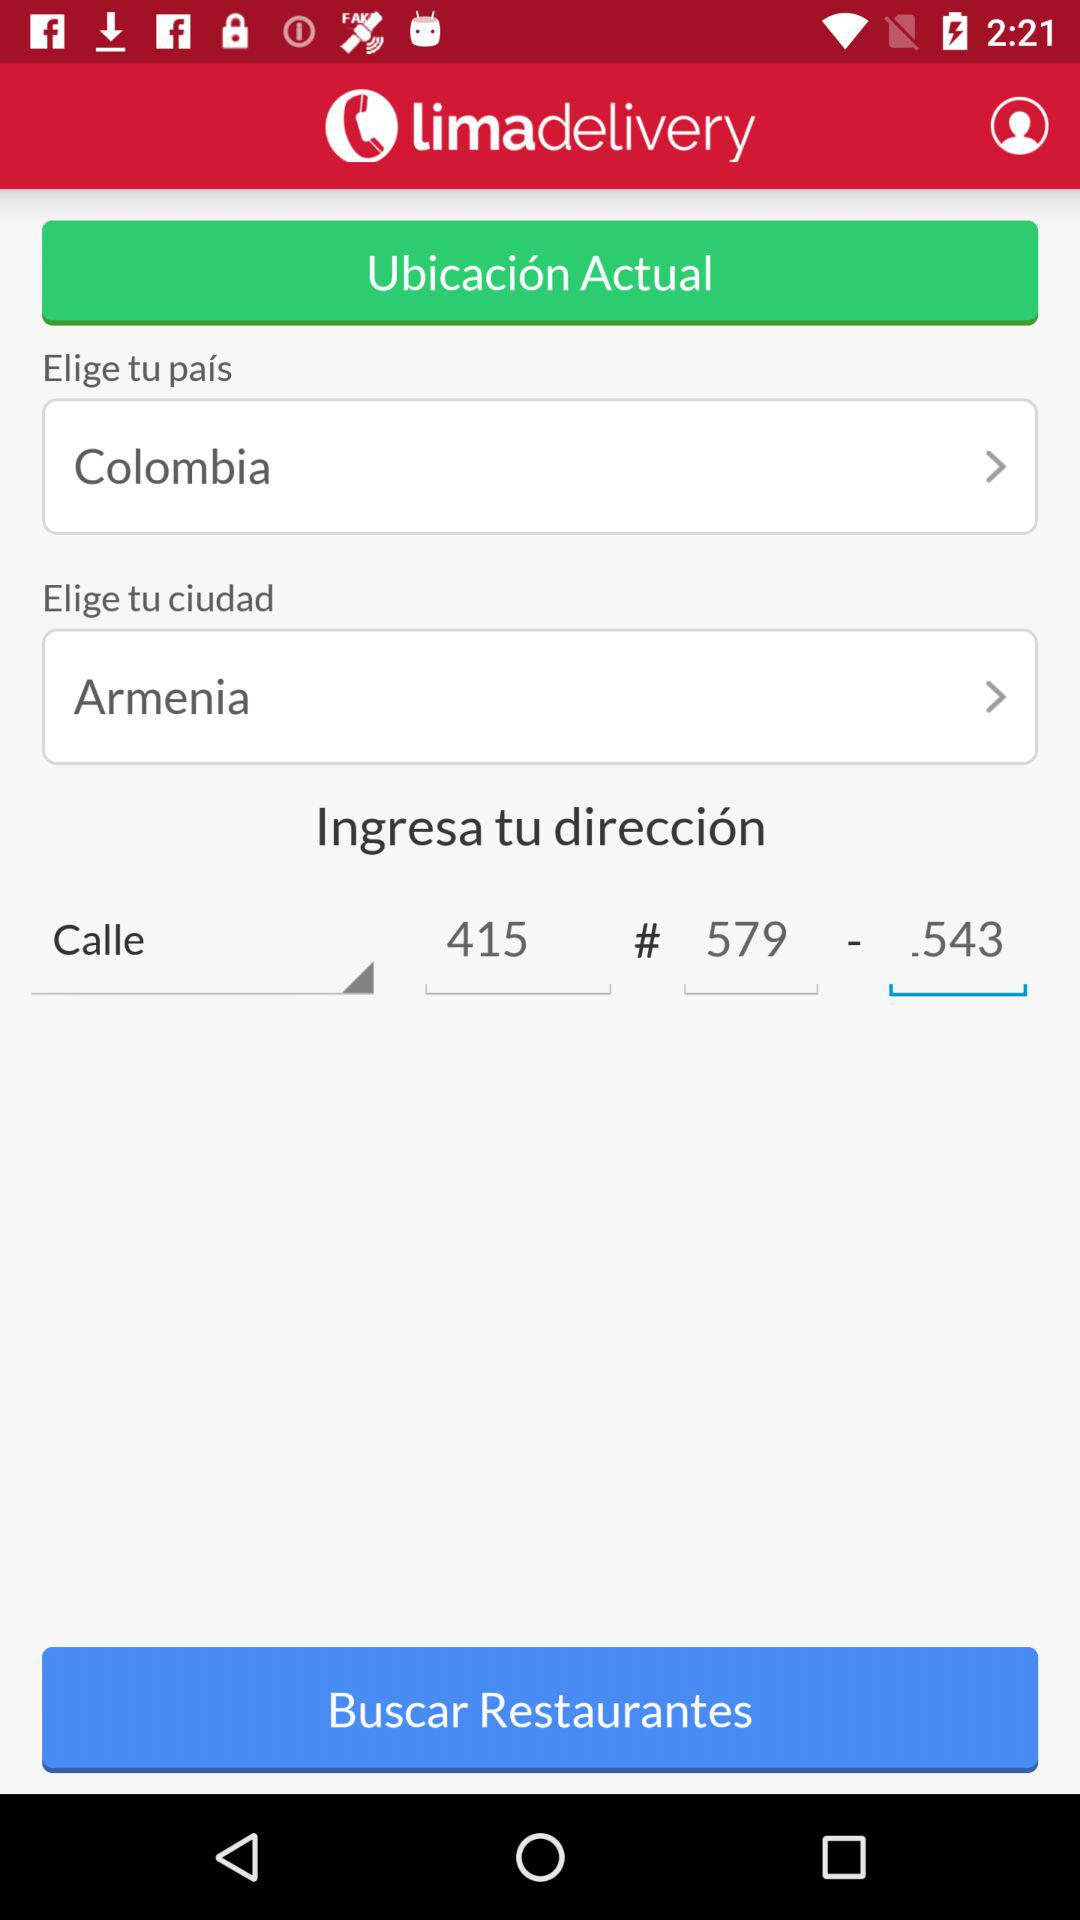How many text inputs have an arrow next to them?
Answer the question using a single word or phrase. 2 